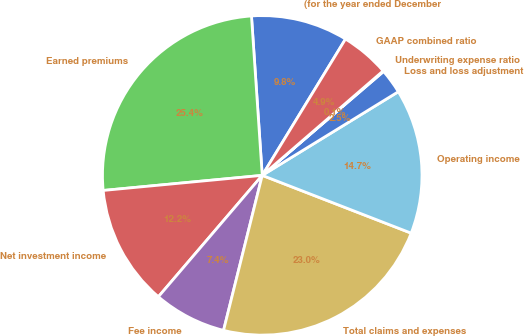<chart> <loc_0><loc_0><loc_500><loc_500><pie_chart><fcel>(for the year ended December<fcel>Earned premiums<fcel>Net investment income<fcel>Fee income<fcel>Total claims and expenses<fcel>Operating income<fcel>Loss and loss adjustment<fcel>Underwriting expense ratio<fcel>GAAP combined ratio<nl><fcel>9.8%<fcel>25.43%<fcel>12.23%<fcel>7.37%<fcel>23.0%<fcel>14.66%<fcel>2.5%<fcel>0.07%<fcel>4.93%<nl></chart> 